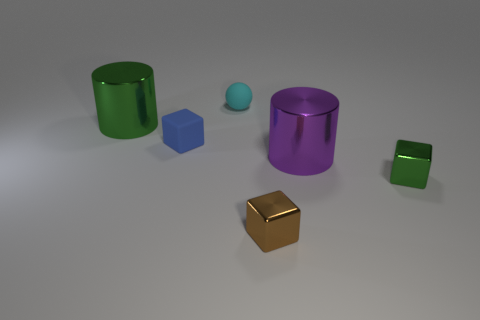Are there any other things that are the same shape as the cyan thing? The cyan object appears to be a sphere, and I can't see any other objects that exactly match its shape in the image. Each object has a distinct shape, like cylinders, cubes, and another sphere with a different color. 